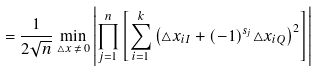<formula> <loc_0><loc_0><loc_500><loc_500>= \frac { 1 } { 2 \sqrt { n } } \min _ { \triangle x \, \neq \, 0 } \left | \prod _ { j = 1 } ^ { n } \left [ \sum _ { i = 1 } ^ { k } { \left ( \triangle x _ { i I } + { \left ( - 1 \right ) } ^ { s _ { j } } \triangle x _ { i Q } \right ) } ^ { 2 } \right ] \right |</formula> 